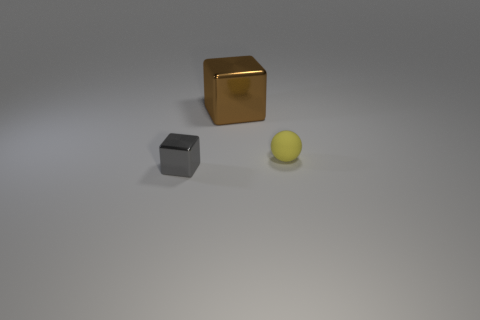Is there anything else that has the same material as the yellow ball?
Provide a short and direct response. No. The small yellow matte object is what shape?
Provide a short and direct response. Sphere. There is a tiny matte sphere; does it have the same color as the metal thing in front of the brown block?
Ensure brevity in your answer.  No. Is the number of objects behind the gray metal block the same as the number of large brown objects?
Make the answer very short. No. How many gray blocks are the same size as the matte ball?
Give a very brief answer. 1. Are there any tiny yellow spheres?
Offer a terse response. Yes. There is a small object behind the gray metallic block; does it have the same shape as the thing that is behind the yellow object?
Keep it short and to the point. No. How many small things are brown cubes or green rubber cylinders?
Offer a terse response. 0. What is the shape of the brown object that is made of the same material as the small block?
Make the answer very short. Cube. Is the shape of the large object the same as the tiny gray object?
Provide a succinct answer. Yes. 